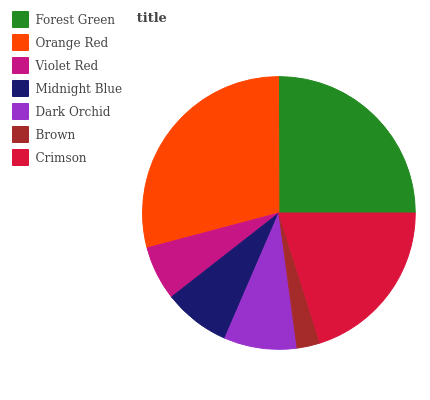Is Brown the minimum?
Answer yes or no. Yes. Is Orange Red the maximum?
Answer yes or no. Yes. Is Violet Red the minimum?
Answer yes or no. No. Is Violet Red the maximum?
Answer yes or no. No. Is Orange Red greater than Violet Red?
Answer yes or no. Yes. Is Violet Red less than Orange Red?
Answer yes or no. Yes. Is Violet Red greater than Orange Red?
Answer yes or no. No. Is Orange Red less than Violet Red?
Answer yes or no. No. Is Dark Orchid the high median?
Answer yes or no. Yes. Is Dark Orchid the low median?
Answer yes or no. Yes. Is Midnight Blue the high median?
Answer yes or no. No. Is Brown the low median?
Answer yes or no. No. 